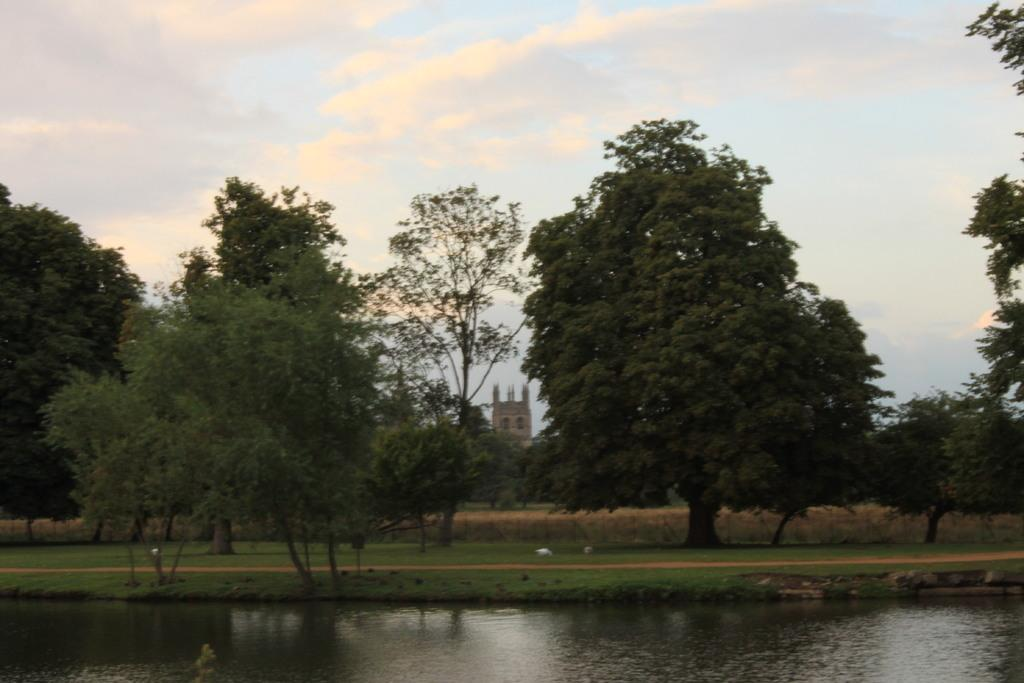What type of vegetation can be seen in the image? There are trees and grass visible in the image. What natural element is present in the image? Water is visible in the image. What can be seen in the background of the image? There is a building and the sky visible in the background of the image. What is the condition of the sky in the image? The sky has clouds in the image. What type of game is being played on the tray in the image? There is no tray or game present in the image. What type of garden can be seen in the image? There is no garden present in the image. 